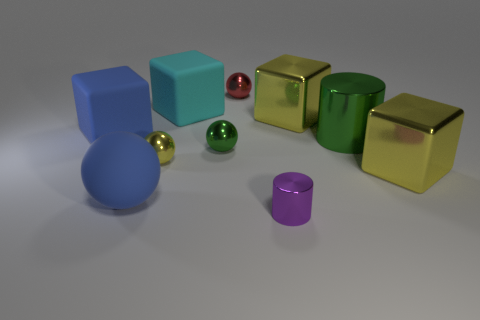Subtract all blue blocks. How many blocks are left? 3 Subtract all yellow cylinders. How many yellow cubes are left? 2 Subtract 2 blocks. How many blocks are left? 2 Subtract all blue cubes. How many cubes are left? 3 Subtract all cylinders. How many objects are left? 8 Subtract all green cubes. Subtract all red cylinders. How many cubes are left? 4 Add 9 yellow metal spheres. How many yellow metal spheres are left? 10 Add 6 tiny things. How many tiny things exist? 10 Subtract 1 red spheres. How many objects are left? 9 Subtract all big cyan cubes. Subtract all big cyan objects. How many objects are left? 8 